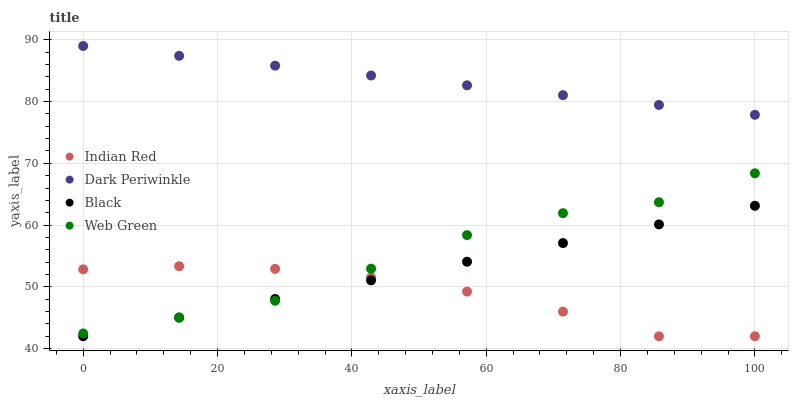Does Indian Red have the minimum area under the curve?
Answer yes or no. Yes. Does Dark Periwinkle have the maximum area under the curve?
Answer yes or no. Yes. Does Black have the minimum area under the curve?
Answer yes or no. No. Does Black have the maximum area under the curve?
Answer yes or no. No. Is Black the smoothest?
Answer yes or no. Yes. Is Web Green the roughest?
Answer yes or no. Yes. Is Dark Periwinkle the smoothest?
Answer yes or no. No. Is Dark Periwinkle the roughest?
Answer yes or no. No. Does Black have the lowest value?
Answer yes or no. Yes. Does Dark Periwinkle have the lowest value?
Answer yes or no. No. Does Dark Periwinkle have the highest value?
Answer yes or no. Yes. Does Black have the highest value?
Answer yes or no. No. Is Black less than Dark Periwinkle?
Answer yes or no. Yes. Is Dark Periwinkle greater than Indian Red?
Answer yes or no. Yes. Does Black intersect Web Green?
Answer yes or no. Yes. Is Black less than Web Green?
Answer yes or no. No. Is Black greater than Web Green?
Answer yes or no. No. Does Black intersect Dark Periwinkle?
Answer yes or no. No. 